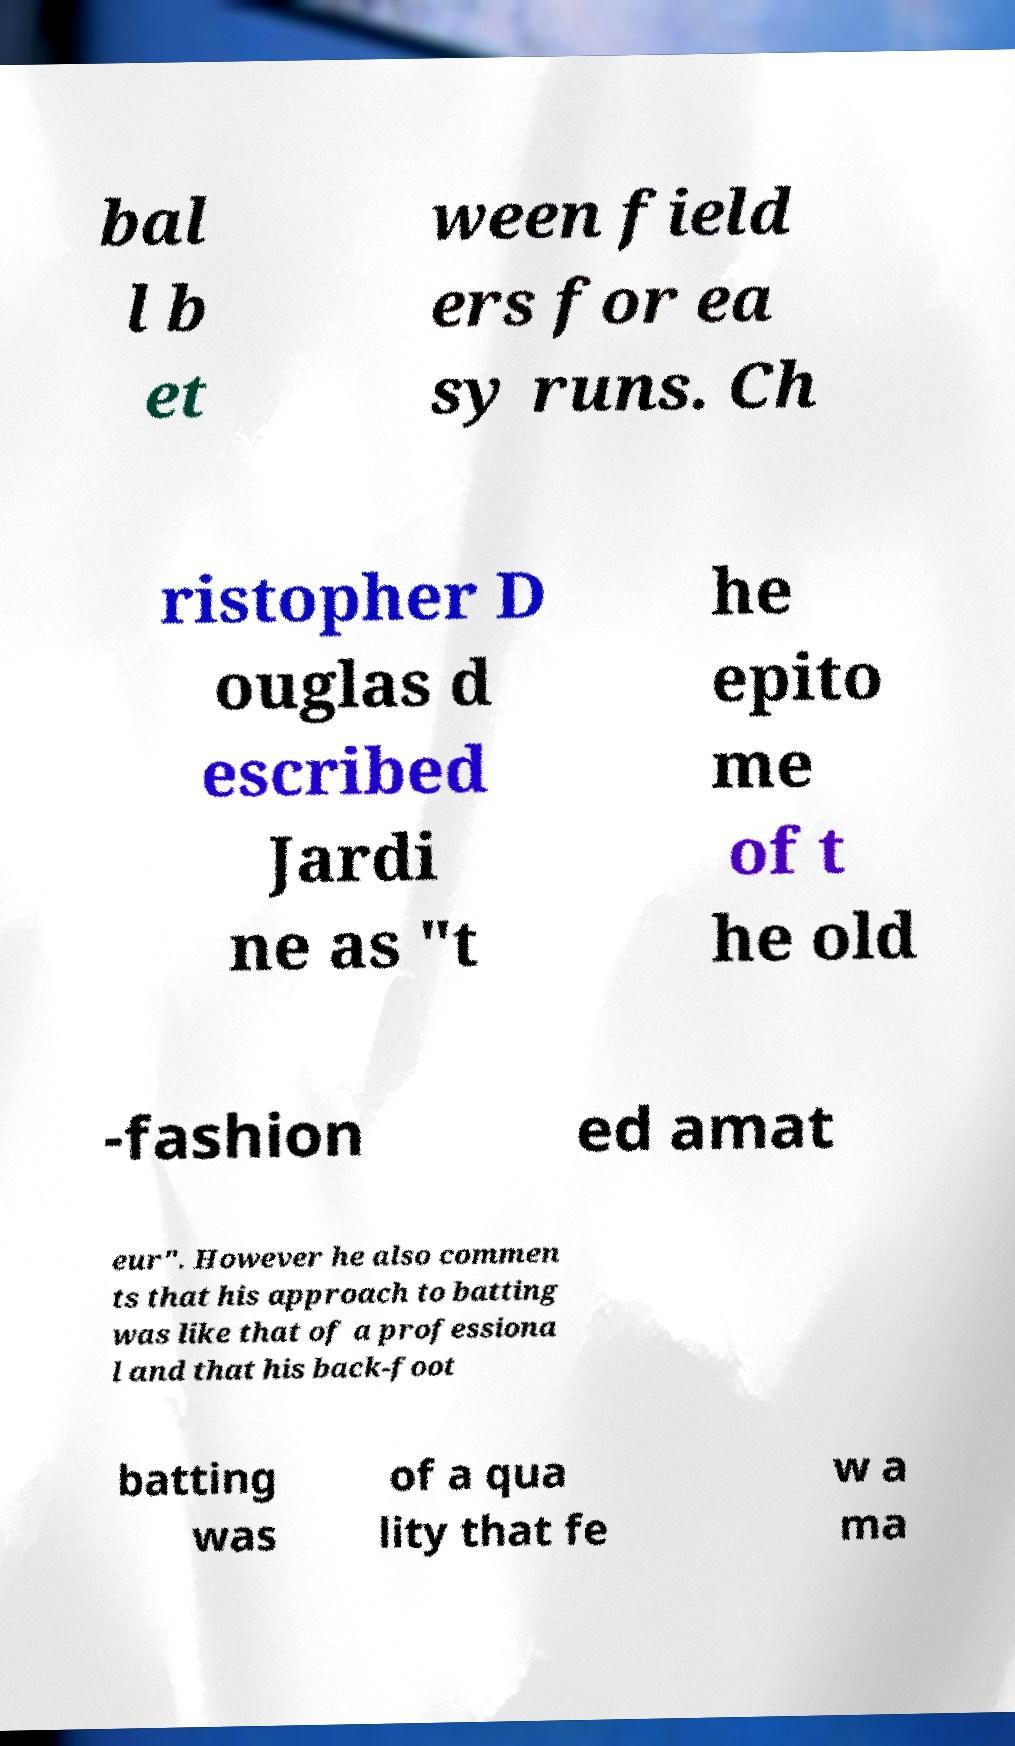For documentation purposes, I need the text within this image transcribed. Could you provide that? bal l b et ween field ers for ea sy runs. Ch ristopher D ouglas d escribed Jardi ne as "t he epito me of t he old -fashion ed amat eur". However he also commen ts that his approach to batting was like that of a professiona l and that his back-foot batting was of a qua lity that fe w a ma 